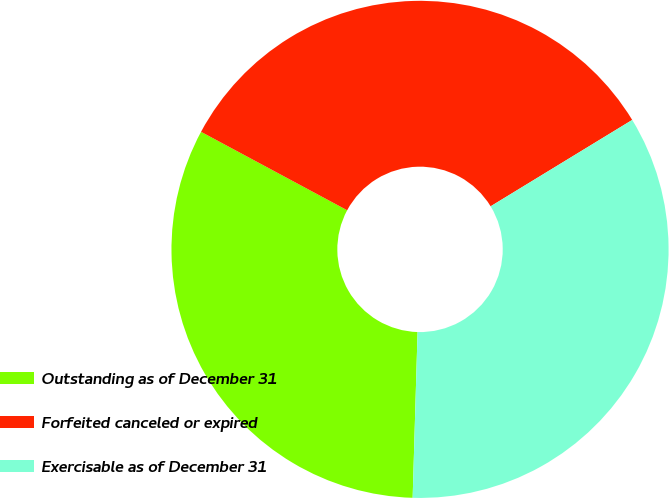Convert chart. <chart><loc_0><loc_0><loc_500><loc_500><pie_chart><fcel>Outstanding as of December 31<fcel>Forfeited canceled or expired<fcel>Exercisable as of December 31<nl><fcel>32.37%<fcel>33.44%<fcel>34.19%<nl></chart> 